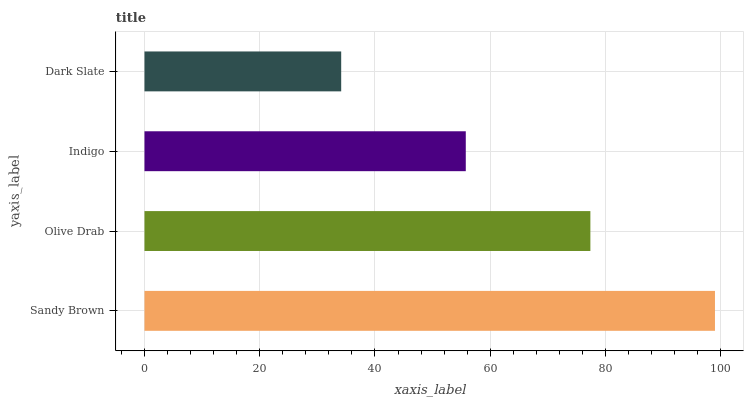Is Dark Slate the minimum?
Answer yes or no. Yes. Is Sandy Brown the maximum?
Answer yes or no. Yes. Is Olive Drab the minimum?
Answer yes or no. No. Is Olive Drab the maximum?
Answer yes or no. No. Is Sandy Brown greater than Olive Drab?
Answer yes or no. Yes. Is Olive Drab less than Sandy Brown?
Answer yes or no. Yes. Is Olive Drab greater than Sandy Brown?
Answer yes or no. No. Is Sandy Brown less than Olive Drab?
Answer yes or no. No. Is Olive Drab the high median?
Answer yes or no. Yes. Is Indigo the low median?
Answer yes or no. Yes. Is Indigo the high median?
Answer yes or no. No. Is Dark Slate the low median?
Answer yes or no. No. 